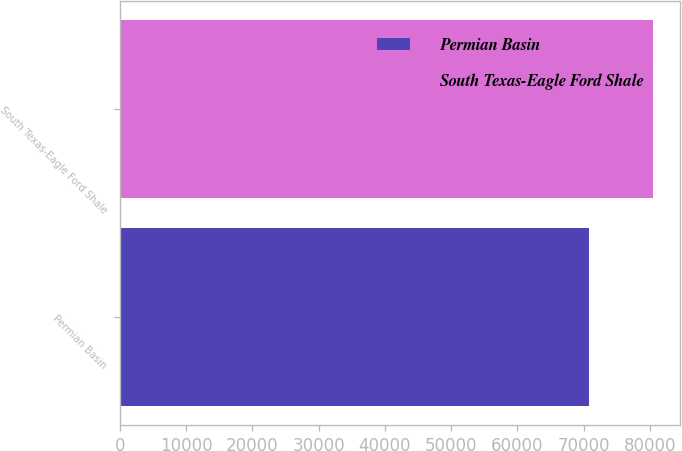Convert chart to OTSL. <chart><loc_0><loc_0><loc_500><loc_500><bar_chart><fcel>Permian Basin<fcel>South Texas-Eagle Ford Shale<nl><fcel>70766<fcel>80458<nl></chart> 